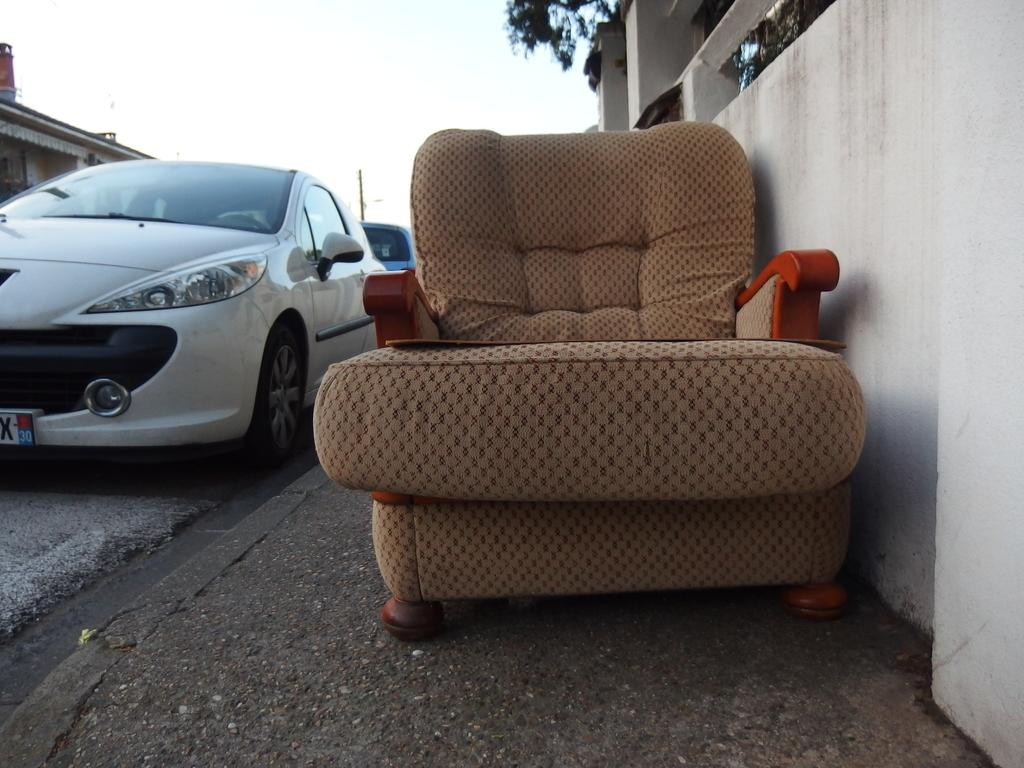What type of furniture is present in the image? There is a chair in the image. What mode of transportation can be seen in the image? There is a car in the road in the image. What natural element is visible in the background of the image? There is a tree in the background of the image. What man-made structure is visible in the background of the image? There is a building in the background of the image. What part of the natural environment is visible in the image? The sky is visible in the background of the image. What vertical object is present in the background of the image? There is a pole in the background of the image. What type of silk material is draped over the car in the image? There is no silk material present in the image; it is a car in the road with no additional fabric draped over it. What type of friction can be observed between the car and the road in the image? The image does not provide enough information to determine the friction between the car and the road. 